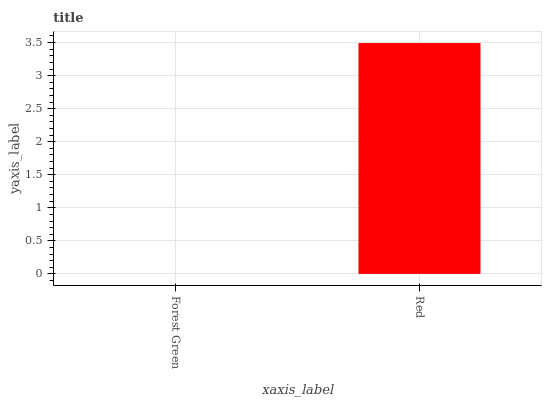Is Forest Green the minimum?
Answer yes or no. Yes. Is Red the maximum?
Answer yes or no. Yes. Is Red the minimum?
Answer yes or no. No. Is Red greater than Forest Green?
Answer yes or no. Yes. Is Forest Green less than Red?
Answer yes or no. Yes. Is Forest Green greater than Red?
Answer yes or no. No. Is Red less than Forest Green?
Answer yes or no. No. Is Red the high median?
Answer yes or no. Yes. Is Forest Green the low median?
Answer yes or no. Yes. Is Forest Green the high median?
Answer yes or no. No. Is Red the low median?
Answer yes or no. No. 